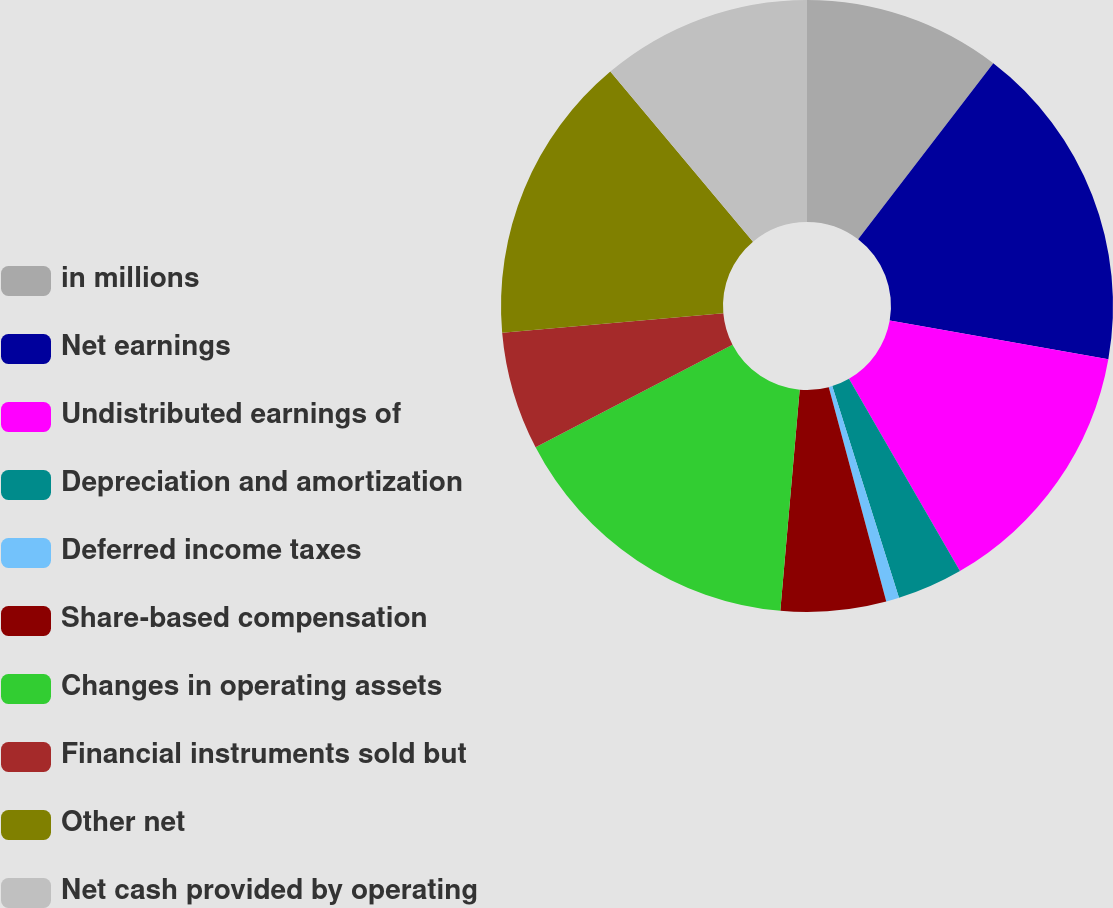Convert chart to OTSL. <chart><loc_0><loc_0><loc_500><loc_500><pie_chart><fcel>in millions<fcel>Net earnings<fcel>Undistributed earnings of<fcel>Depreciation and amortization<fcel>Deferred income taxes<fcel>Share-based compensation<fcel>Changes in operating assets<fcel>Financial instruments sold but<fcel>Other net<fcel>Net cash provided by operating<nl><fcel>10.42%<fcel>17.36%<fcel>13.89%<fcel>3.47%<fcel>0.69%<fcel>5.56%<fcel>15.97%<fcel>6.25%<fcel>15.28%<fcel>11.11%<nl></chart> 